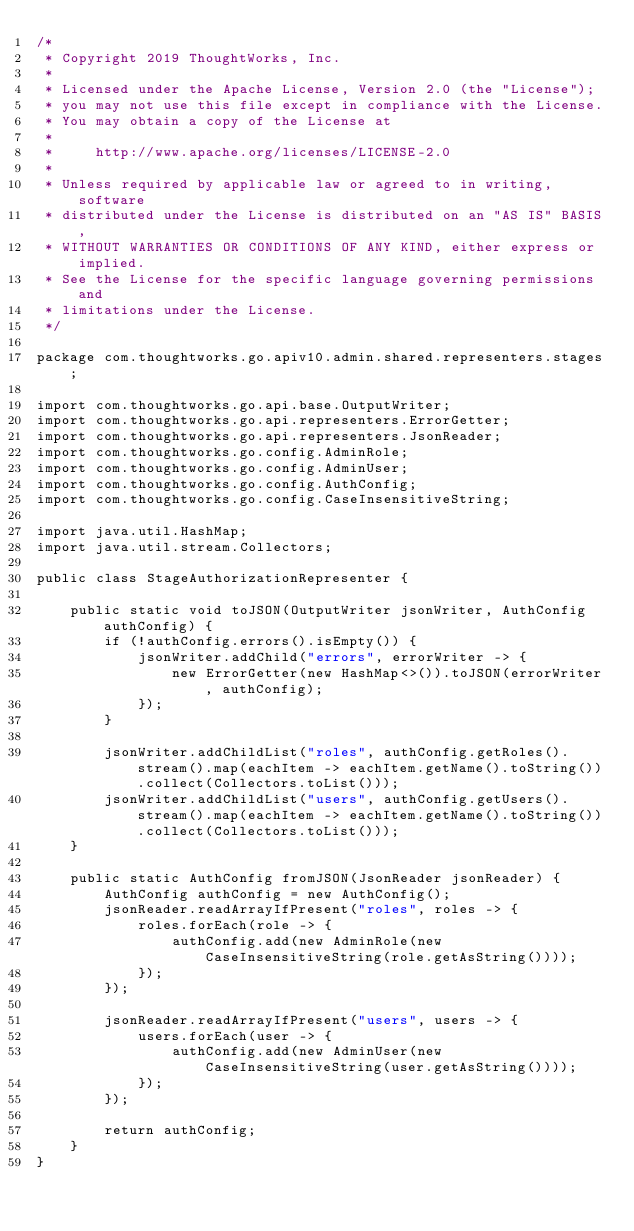<code> <loc_0><loc_0><loc_500><loc_500><_Java_>/*
 * Copyright 2019 ThoughtWorks, Inc.
 *
 * Licensed under the Apache License, Version 2.0 (the "License");
 * you may not use this file except in compliance with the License.
 * You may obtain a copy of the License at
 *
 *     http://www.apache.org/licenses/LICENSE-2.0
 *
 * Unless required by applicable law or agreed to in writing, software
 * distributed under the License is distributed on an "AS IS" BASIS,
 * WITHOUT WARRANTIES OR CONDITIONS OF ANY KIND, either express or implied.
 * See the License for the specific language governing permissions and
 * limitations under the License.
 */

package com.thoughtworks.go.apiv10.admin.shared.representers.stages;

import com.thoughtworks.go.api.base.OutputWriter;
import com.thoughtworks.go.api.representers.ErrorGetter;
import com.thoughtworks.go.api.representers.JsonReader;
import com.thoughtworks.go.config.AdminRole;
import com.thoughtworks.go.config.AdminUser;
import com.thoughtworks.go.config.AuthConfig;
import com.thoughtworks.go.config.CaseInsensitiveString;

import java.util.HashMap;
import java.util.stream.Collectors;

public class StageAuthorizationRepresenter {

    public static void toJSON(OutputWriter jsonWriter, AuthConfig authConfig) {
        if (!authConfig.errors().isEmpty()) {
            jsonWriter.addChild("errors", errorWriter -> {
                new ErrorGetter(new HashMap<>()).toJSON(errorWriter, authConfig);
            });
        }

        jsonWriter.addChildList("roles", authConfig.getRoles().stream().map(eachItem -> eachItem.getName().toString()).collect(Collectors.toList()));
        jsonWriter.addChildList("users", authConfig.getUsers().stream().map(eachItem -> eachItem.getName().toString()).collect(Collectors.toList()));
    }

    public static AuthConfig fromJSON(JsonReader jsonReader) {
        AuthConfig authConfig = new AuthConfig();
        jsonReader.readArrayIfPresent("roles", roles -> {
            roles.forEach(role -> {
                authConfig.add(new AdminRole(new CaseInsensitiveString(role.getAsString())));
            });
        });

        jsonReader.readArrayIfPresent("users", users -> {
            users.forEach(user -> {
                authConfig.add(new AdminUser(new CaseInsensitiveString(user.getAsString())));
            });
        });

        return authConfig;
    }
}
</code> 